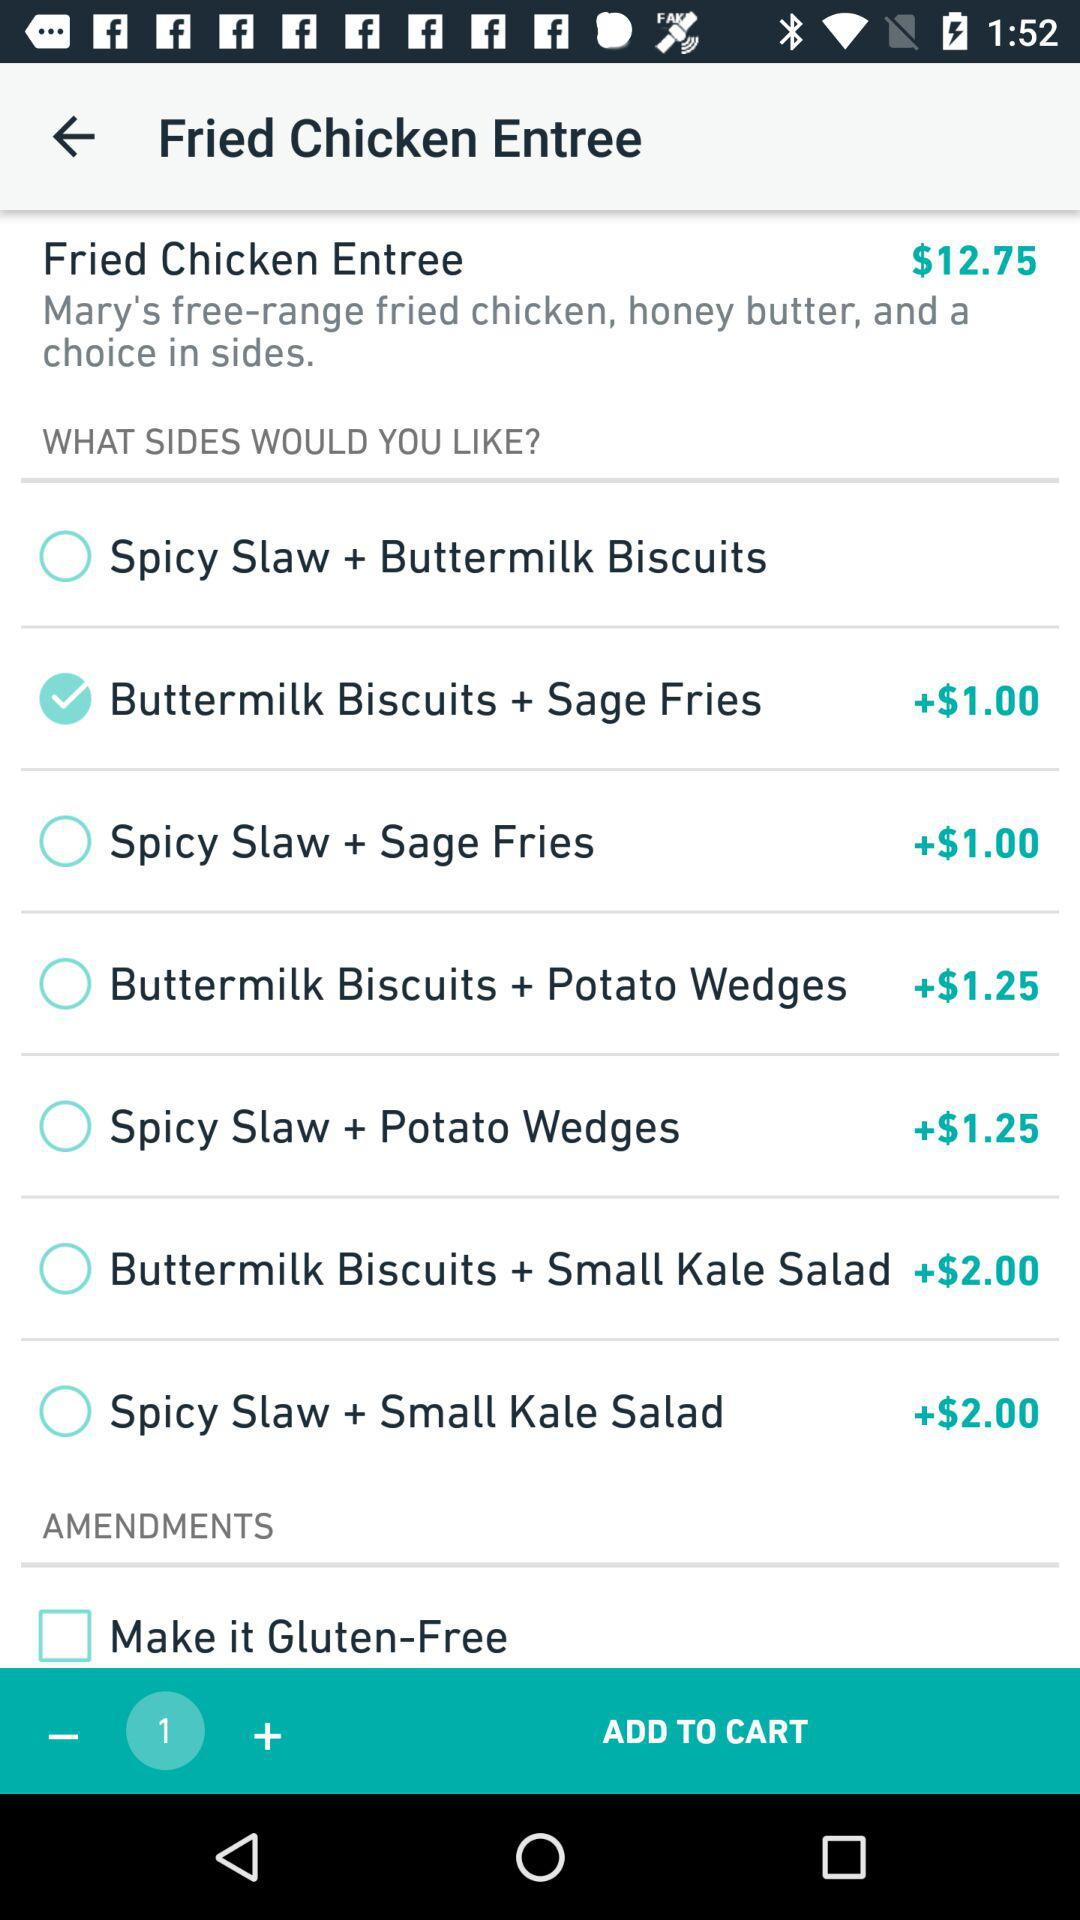What is the price of "Fried Chicken Entree"? The price of "Fried Chicken Entree" is $12.75. 